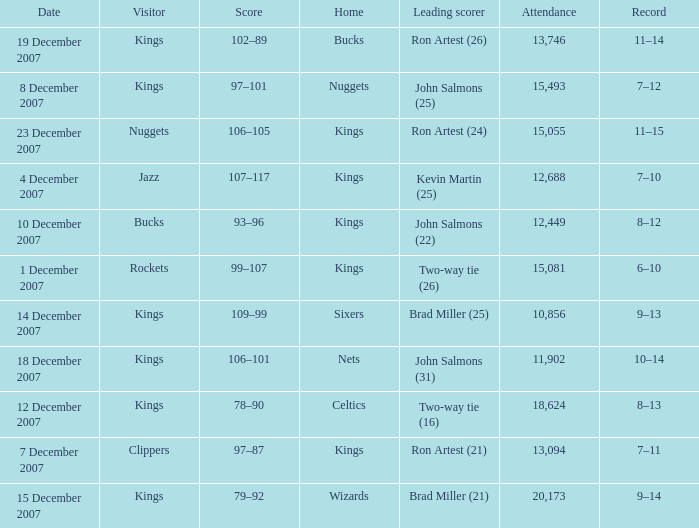What was the record of the game where the Rockets were the visiting team? 6–10. 